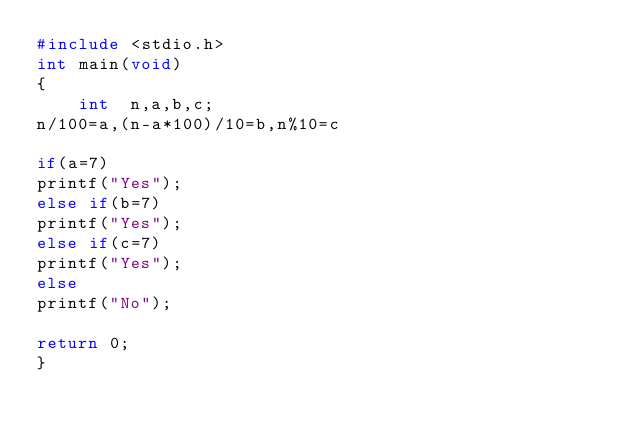<code> <loc_0><loc_0><loc_500><loc_500><_C_>#include <stdio.h>
int main(void)
{
    int  n,a,b,c;
n/100=a,(n-a*100)/10=b,n%10=c
    
if(a=7)
printf("Yes");
else if(b=7)
printf("Yes");
else if(c=7)
printf("Yes");
else
printf("No");

return 0;
}</code> 